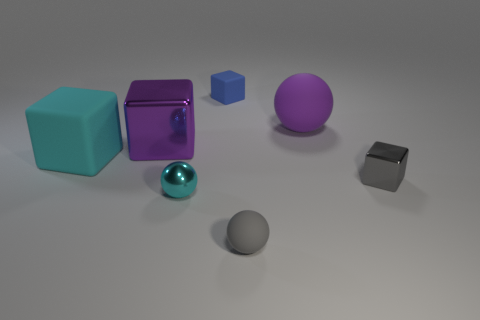Can you describe the lighting and shadows in the scene? The scene is illuminated by a soft, diffuse light source that casts gentle, barely perceptible shadows beneath the objects. The direction of the light appears to be from the upper left, as indicated by the highlights on the objects and the position of shadows to the right side of each item, which contributes to the calm and balanced ambiance of the image. 